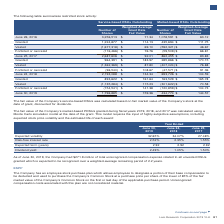According to Lam Research Corporation's financial document, How was the fair value of the Company’s service-based RSUs calculated? based on fair market value of the Company’s stock at the date of grant, discounted for dividends. The document states: "f the Company’s service-based RSUs was calculated based on fair market value of the Company’s stock at the date of grant, discounted for dividends...." Also, Which model was used for the calculation of the fair value of the Company’s market-based PRSUs granted during fiscal years 2019, 2018, and 2017? Monte Carlo simulation model. The document states: "years 2019, 2018, and 2017 was calculated using a Monte Carlo simulation model at the date of the grant. This model requires the input of highly subje..." Also, What is the amount of total unrecognised compensation expense as of June 30, 2019? According to the financial document, $271.9 million. The relevant text states: "As of June 30, 2019, the Company had $271.9 million of total unrecognized compensation expense related to all unvested RSUs granted which is expected to..." Also, can you calculate: What is the change in the expected volatility from 2018 to 2019? Based on the calculation: 32.65-34.07, the result is -1.42 (percentage). This is based on the information: "Expected volatility 32.65% 34.07% 27.48% Expected volatility 32.65% 34.07% 27.48%..." The key data points involved are: 32.65, 34.07. Also, can you calculate: What is the change in the risk-free interest rate from 2018 to 2019? Based on the calculation: 2.52-2.35, the result is 0.17 (percentage). This is based on the information: "Risk-free interest rate 2.52% 2.35% 1.55% Risk-free interest rate 2.52% 2.35% 1.55%..." The key data points involved are: 2.35, 2.52. Also, can you calculate: What is the change in the dividend yield from 2018 to 2019? Based on the calculation: 2.49-1.05, the result is 1.44 (percentage). This is based on the information: "Dividend yield 2.49% 1.05% 1.50% Dividend yield 2.49% 1.05% 1.50%..." The key data points involved are: 1.05, 2.49. 